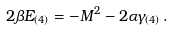Convert formula to latex. <formula><loc_0><loc_0><loc_500><loc_500>2 \beta E _ { ( 4 ) } = - M ^ { 2 } - 2 \alpha \gamma _ { ( 4 ) } \, .</formula> 